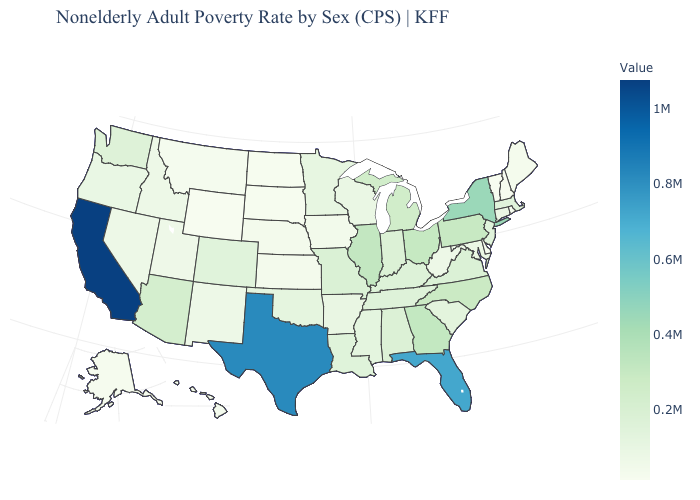Does California have the highest value in the USA?
Write a very short answer. Yes. Does North Dakota have a higher value than Indiana?
Quick response, please. No. Among the states that border New York , does Vermont have the highest value?
Quick response, please. No. Does Wyoming have the lowest value in the USA?
Give a very brief answer. Yes. Which states have the highest value in the USA?
Quick response, please. California. Does Connecticut have the highest value in the Northeast?
Answer briefly. No. Does Virginia have the lowest value in the USA?
Give a very brief answer. No. Which states have the lowest value in the USA?
Answer briefly. Wyoming. Among the states that border Michigan , which have the lowest value?
Give a very brief answer. Wisconsin. Is the legend a continuous bar?
Short answer required. Yes. Does Rhode Island have the highest value in the USA?
Answer briefly. No. 